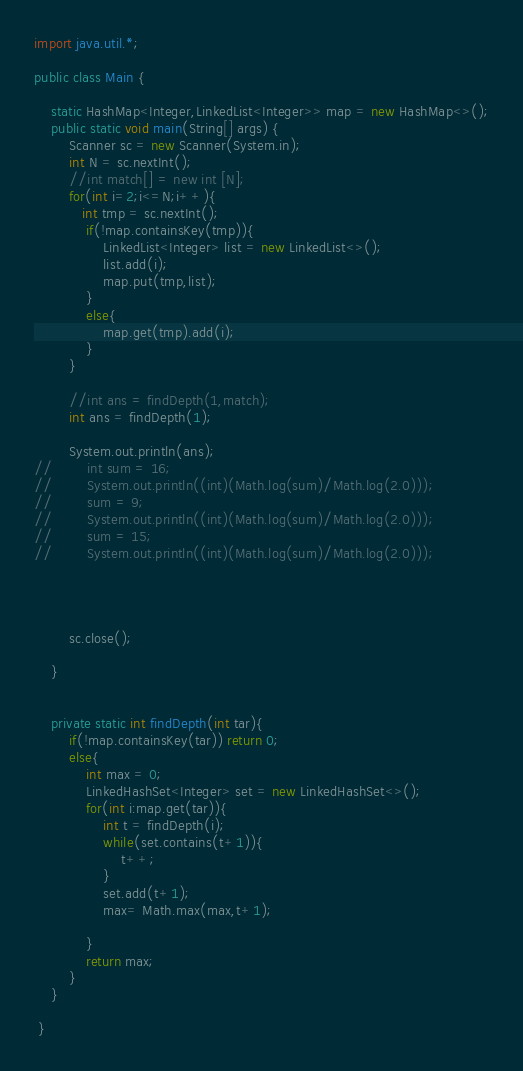<code> <loc_0><loc_0><loc_500><loc_500><_Java_>import java.util.*;

public class Main {

    static HashMap<Integer,LinkedList<Integer>> map = new HashMap<>();
    public static void main(String[] args) {
        Scanner sc = new Scanner(System.in);
        int N = sc.nextInt();
        //int match[] = new int [N];
        for(int i=2;i<=N;i++){
           int tmp = sc.nextInt();
            if(!map.containsKey(tmp)){
                LinkedList<Integer> list = new LinkedList<>();
                list.add(i);
                map.put(tmp,list);
            }
            else{
                map.get(tmp).add(i);
            }
        }

        //int ans = findDepth(1,match);
        int ans = findDepth(1);

        System.out.println(ans);
//        int sum = 16;
//        System.out.println((int)(Math.log(sum)/Math.log(2.0)));
//        sum = 9;
//        System.out.println((int)(Math.log(sum)/Math.log(2.0)));
//        sum = 15;
//        System.out.println((int)(Math.log(sum)/Math.log(2.0)));




        sc.close();

    }


    private static int findDepth(int tar){
        if(!map.containsKey(tar)) return 0;
        else{
            int max = 0;
            LinkedHashSet<Integer> set = new LinkedHashSet<>();
            for(int i:map.get(tar)){
                int t = findDepth(i);
                while(set.contains(t+1)){
                    t++;
                }
                set.add(t+1);
                max= Math.max(max,t+1);

            }
            return max;
        }
    }

 }
</code> 